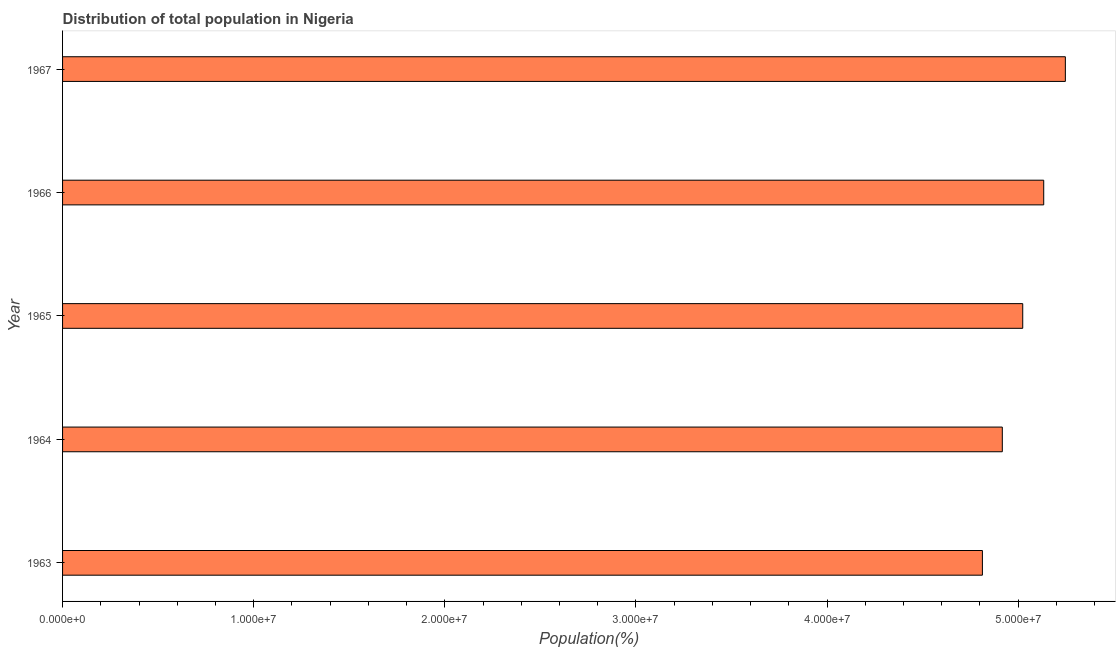Does the graph contain grids?
Provide a short and direct response. No. What is the title of the graph?
Keep it short and to the point. Distribution of total population in Nigeria . What is the label or title of the X-axis?
Your answer should be very brief. Population(%). What is the label or title of the Y-axis?
Make the answer very short. Year. What is the population in 1967?
Offer a very short reply. 5.25e+07. Across all years, what is the maximum population?
Your response must be concise. 5.25e+07. Across all years, what is the minimum population?
Keep it short and to the point. 4.81e+07. In which year was the population maximum?
Give a very brief answer. 1967. In which year was the population minimum?
Keep it short and to the point. 1963. What is the sum of the population?
Offer a terse response. 2.51e+08. What is the difference between the population in 1965 and 1967?
Offer a terse response. -2.23e+06. What is the average population per year?
Offer a terse response. 5.03e+07. What is the median population?
Keep it short and to the point. 5.02e+07. In how many years, is the population greater than 6000000 %?
Keep it short and to the point. 5. Do a majority of the years between 1965 and 1963 (inclusive) have population greater than 44000000 %?
Make the answer very short. Yes. What is the ratio of the population in 1963 to that in 1966?
Keep it short and to the point. 0.94. Is the population in 1964 less than that in 1967?
Your answer should be very brief. Yes. What is the difference between the highest and the second highest population?
Give a very brief answer. 1.13e+06. Is the sum of the population in 1963 and 1964 greater than the maximum population across all years?
Keep it short and to the point. Yes. What is the difference between the highest and the lowest population?
Provide a succinct answer. 4.34e+06. In how many years, is the population greater than the average population taken over all years?
Offer a very short reply. 2. Are all the bars in the graph horizontal?
Ensure brevity in your answer.  Yes. What is the Population(%) of 1963?
Your answer should be compact. 4.81e+07. What is the Population(%) of 1964?
Keep it short and to the point. 4.92e+07. What is the Population(%) of 1965?
Ensure brevity in your answer.  5.02e+07. What is the Population(%) in 1966?
Your response must be concise. 5.13e+07. What is the Population(%) in 1967?
Your response must be concise. 5.25e+07. What is the difference between the Population(%) in 1963 and 1964?
Provide a succinct answer. -1.04e+06. What is the difference between the Population(%) in 1963 and 1965?
Make the answer very short. -2.11e+06. What is the difference between the Population(%) in 1963 and 1966?
Provide a short and direct response. -3.21e+06. What is the difference between the Population(%) in 1963 and 1967?
Your answer should be very brief. -4.34e+06. What is the difference between the Population(%) in 1964 and 1965?
Your answer should be compact. -1.07e+06. What is the difference between the Population(%) in 1964 and 1966?
Give a very brief answer. -2.17e+06. What is the difference between the Population(%) in 1964 and 1967?
Provide a short and direct response. -3.30e+06. What is the difference between the Population(%) in 1965 and 1966?
Your response must be concise. -1.10e+06. What is the difference between the Population(%) in 1965 and 1967?
Provide a succinct answer. -2.23e+06. What is the difference between the Population(%) in 1966 and 1967?
Your response must be concise. -1.13e+06. What is the ratio of the Population(%) in 1963 to that in 1964?
Your answer should be very brief. 0.98. What is the ratio of the Population(%) in 1963 to that in 1965?
Offer a terse response. 0.96. What is the ratio of the Population(%) in 1963 to that in 1966?
Your answer should be very brief. 0.94. What is the ratio of the Population(%) in 1963 to that in 1967?
Offer a terse response. 0.92. What is the ratio of the Population(%) in 1964 to that in 1966?
Give a very brief answer. 0.96. What is the ratio of the Population(%) in 1964 to that in 1967?
Ensure brevity in your answer.  0.94. What is the ratio of the Population(%) in 1965 to that in 1966?
Offer a terse response. 0.98. What is the ratio of the Population(%) in 1966 to that in 1967?
Make the answer very short. 0.98. 